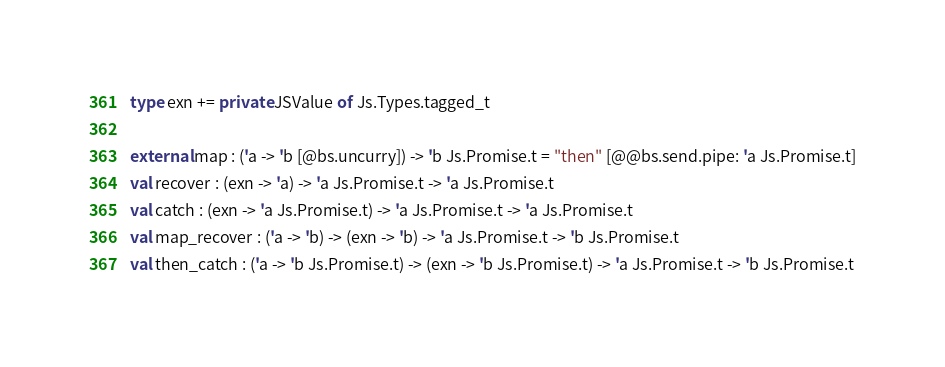Convert code to text. <code><loc_0><loc_0><loc_500><loc_500><_OCaml_>type exn += private JSValue of Js.Types.tagged_t

external map : ('a -> 'b [@bs.uncurry]) -> 'b Js.Promise.t = "then" [@@bs.send.pipe: 'a Js.Promise.t]
val recover : (exn -> 'a) -> 'a Js.Promise.t -> 'a Js.Promise.t
val catch : (exn -> 'a Js.Promise.t) -> 'a Js.Promise.t -> 'a Js.Promise.t
val map_recover : ('a -> 'b) -> (exn -> 'b) -> 'a Js.Promise.t -> 'b Js.Promise.t
val then_catch : ('a -> 'b Js.Promise.t) -> (exn -> 'b Js.Promise.t) -> 'a Js.Promise.t -> 'b Js.Promise.t
</code> 